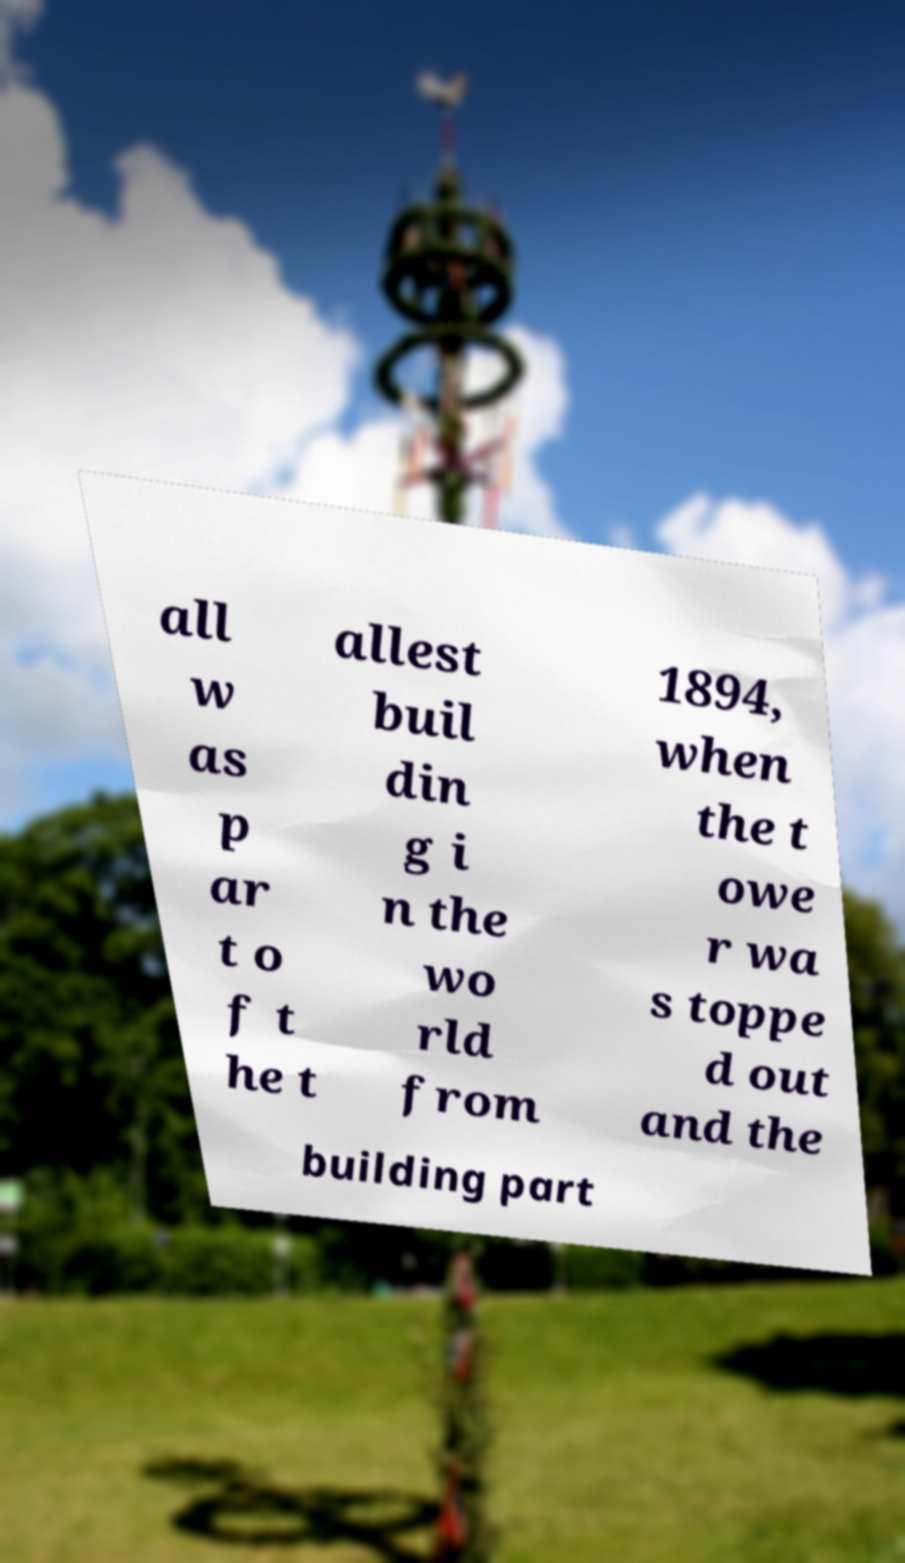What messages or text are displayed in this image? I need them in a readable, typed format. all w as p ar t o f t he t allest buil din g i n the wo rld from 1894, when the t owe r wa s toppe d out and the building part 